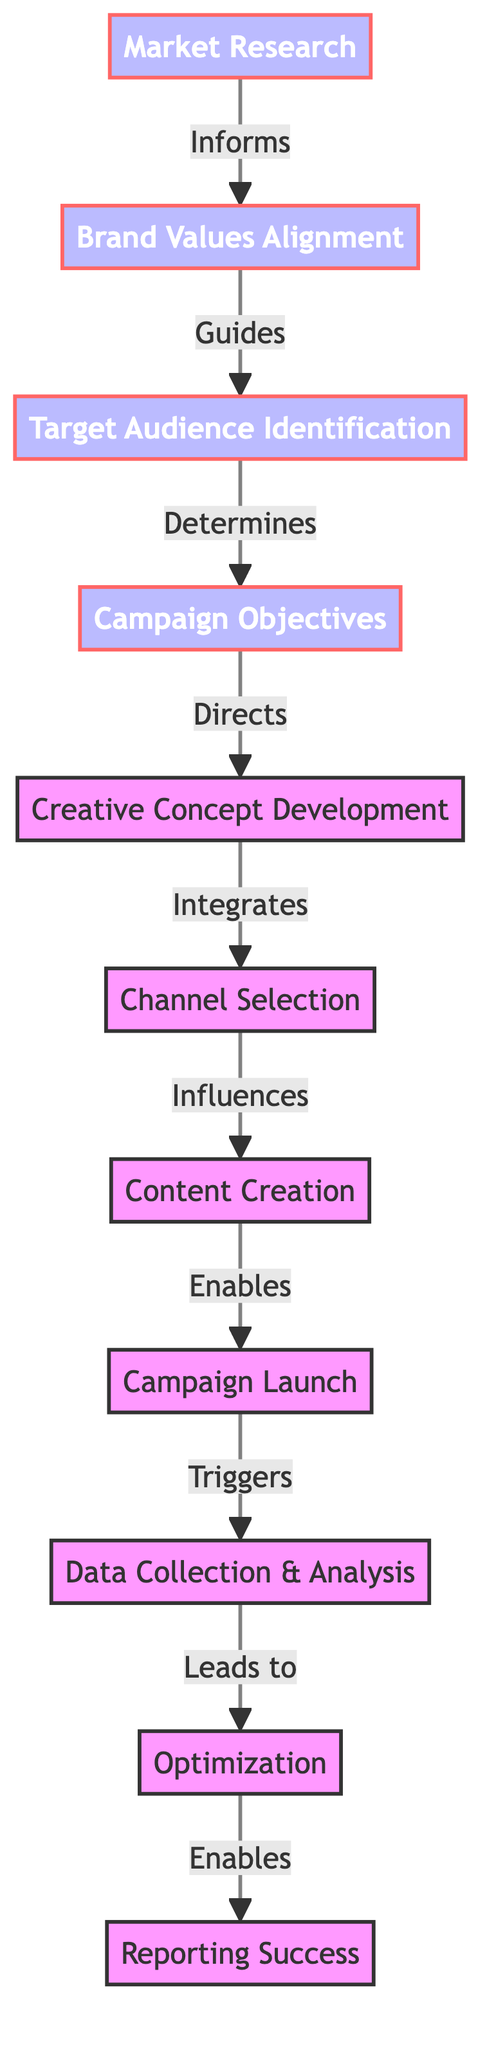What is the first step in the marketing campaign process? The diagram's first node is "Market Research," indicating it is the initial step in the marketing campaign process.
Answer: Market Research How many total steps are shown in the diagram? Counting the nodes presented in the diagram, there are a total of 11 steps from "Market Research" to "Reporting Success."
Answer: 11 What step follows "Creative Concept Development"? The diagram indicates that after "Creative Concept Development," the next step is "Channel Selection."
Answer: Channel Selection What does "Data Collection & Analysis" lead to? According to the flow in the diagram, "Data Collection & Analysis" leads to the step of "Optimization."
Answer: Optimization Which two steps directly guide each other? The steps "Market Research" and "Brand Values Alignment" guide each other as indicated by their directional relationship in the flowchart.
Answer: Market Research and Brand Values Alignment What role does "Brand Values Alignment" play in the campaign process? "Brand Values Alignment" informs the next step, indicating that it helps to shape and ensure the marketing campaign aligns with the brand's values.
Answer: Informs How does "Content Creation" relate to "Campaign Launch"? The relationship shown in the diagram indicates that "Content Creation" enables the "Campaign Launch," meaning the content is necessary for launching the campaign.
Answer: Enables What is the last step in the marketing campaign process? The final node in the diagram is "Reporting Success," making it the concluding step of the marketing campaign process.
Answer: Reporting Success Which step influences "Content Creation"? According to the diagram, the step "Channel Selection" influences "Content Creation," meaning the choice of channels impacts the type of content created.
Answer: Channel Selection What is the relationship between "Optimization" and "Reporting Success"? The diagram shows that "Optimization" enables "Reporting Success," indicating that improvements made through optimization lead to successful results reporting.
Answer: Enables 